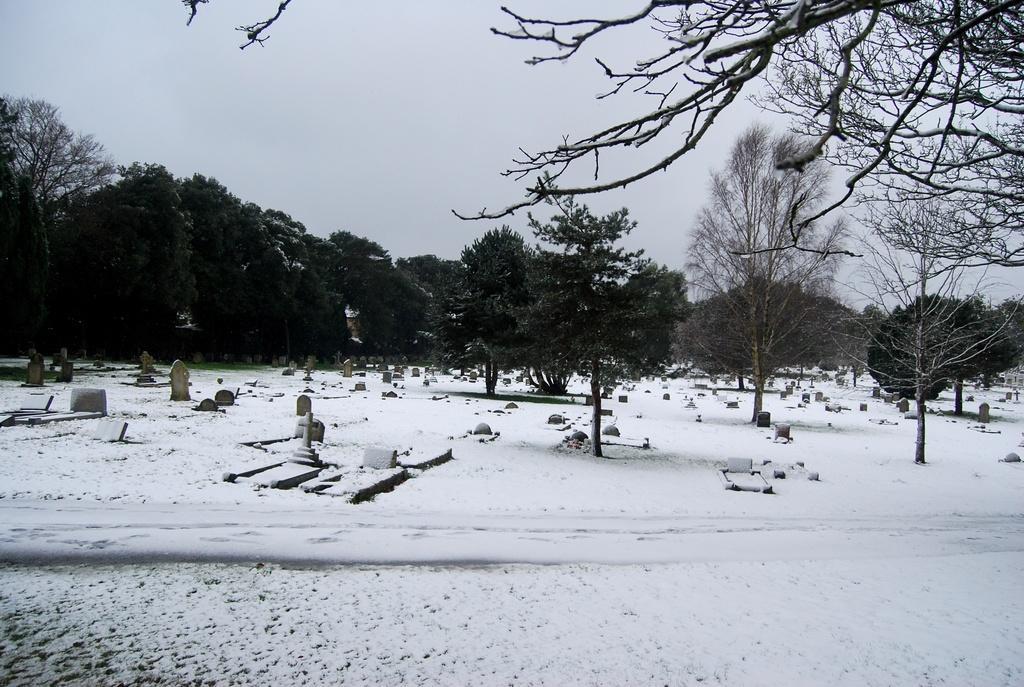Please provide a concise description of this image. In this picture we can see some objects on snow and in the background we can see trees and the sky. 